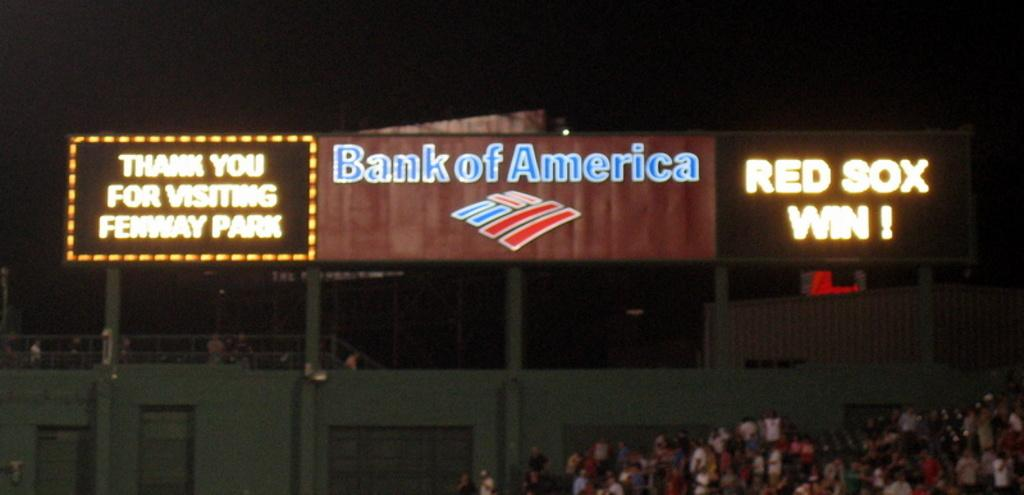What type of structure is present in the image? There is a building in the image. What is located near the building? There is a fence in the image. What can be seen on the boards in the image? There are boards with text in the image. What can be observed in terms of illumination in the image? There is light visible in the image. What type of vegetation is in front of the building? There is a tree in front of the building in the image. What type of death is being discussed on the boards in the image? There is no mention of death on the boards in the image; they contain text about other topics. What type of exchange is taking place in front of the building? There is no exchange taking place in front of the building in the image; it simply shows a tree. 